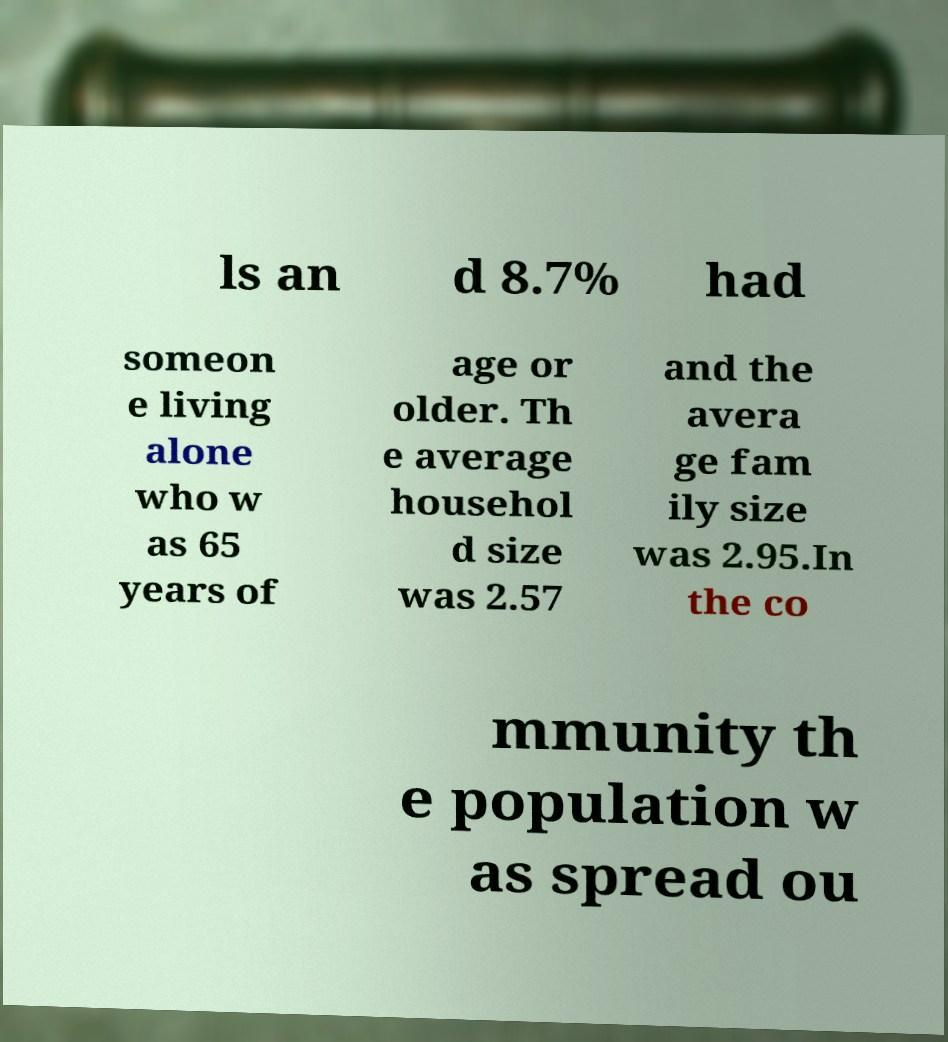Please identify and transcribe the text found in this image. ls an d 8.7% had someon e living alone who w as 65 years of age or older. Th e average househol d size was 2.57 and the avera ge fam ily size was 2.95.In the co mmunity th e population w as spread ou 